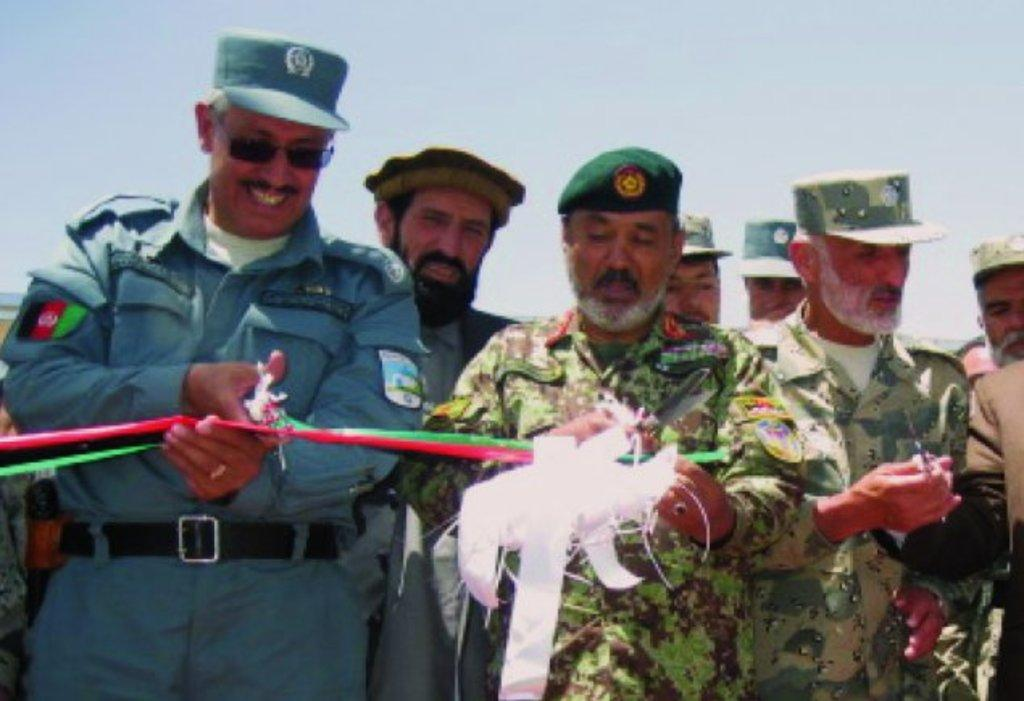How many people are in the center of the image? There are two people standing in the center of the image. What are the two people in the center doing? The two people are cutting a ribbon. Can you describe the people in the background of the image? There are people in the background of the image, but their specific actions or appearances are not mentioned in the provided facts. What is visible at the top of the image? The sky is visible at the top of the image. What type of stone is being used to twist the ribbon in the image? There is no stone present in the image, and the ribbon is being cut, not twisted. 